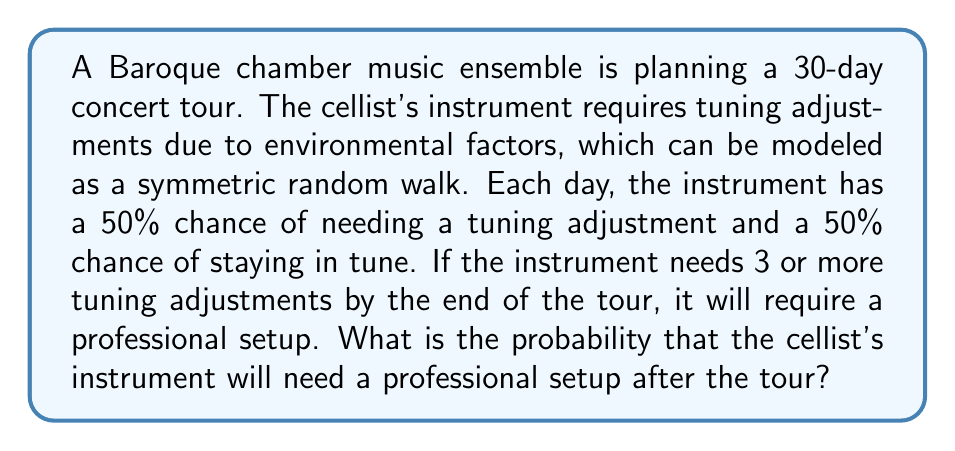Give your solution to this math problem. Let's approach this step-by-step:

1) This situation can be modeled as a binomial distribution, where each day is an independent trial with a probability of success (needing tuning) of 0.5.

2) We need to find the probability of having 3 or more successes in 30 trials.

3) Let X be the number of tuning adjustments needed. We want to find P(X ≥ 3).

4) This is equivalent to 1 - P(X < 3) = 1 - [P(X=0) + P(X=1) + P(X=2)]

5) The probability mass function for a binomial distribution is:

   $$P(X=k) = \binom{n}{k} p^k (1-p)^{n-k}$$

   where n is the number of trials, k is the number of successes, and p is the probability of success on each trial.

6) In our case, n = 30, p = 0.5, and we need to calculate for k = 0, 1, and 2:

   $$P(X=0) = \binom{30}{0} (0.5)^0 (0.5)^{30} = (0.5)^{30}$$
   
   $$P(X=1) = \binom{30}{1} (0.5)^1 (0.5)^{29} = 30 \cdot (0.5)^{30}$$
   
   $$P(X=2) = \binom{30}{2} (0.5)^2 (0.5)^{28} = 435 \cdot (0.5)^{30}$$

7) Adding these up:

   $$P(X < 3) = (0.5)^{30} + 30 \cdot (0.5)^{30} + 435 \cdot (0.5)^{30} = 466 \cdot (0.5)^{30}$$

8) Therefore, the probability of needing 3 or more tuning adjustments is:

   $$P(X \geq 3) = 1 - 466 \cdot (0.5)^{30} \approx 0.9999999981$$
Answer: 0.9999999981 